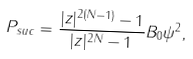<formula> <loc_0><loc_0><loc_500><loc_500>P _ { s u c } = \frac { | z | ^ { 2 ( N - 1 ) } - 1 } { | z | ^ { 2 N } - 1 } \| B _ { 0 } \psi \| ^ { 2 } ,</formula> 